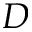<formula> <loc_0><loc_0><loc_500><loc_500>D</formula> 